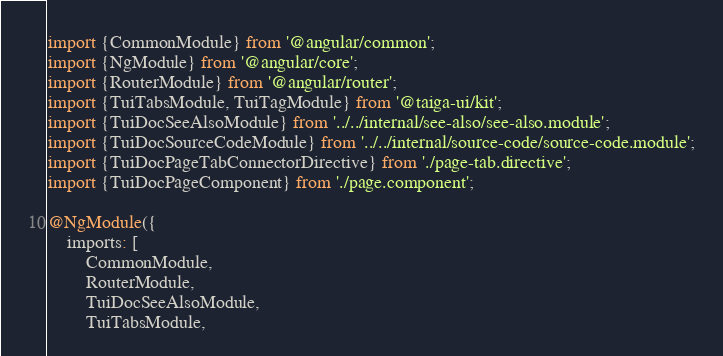Convert code to text. <code><loc_0><loc_0><loc_500><loc_500><_TypeScript_>import {CommonModule} from '@angular/common';
import {NgModule} from '@angular/core';
import {RouterModule} from '@angular/router';
import {TuiTabsModule, TuiTagModule} from '@taiga-ui/kit';
import {TuiDocSeeAlsoModule} from '../../internal/see-also/see-also.module';
import {TuiDocSourceCodeModule} from '../../internal/source-code/source-code.module';
import {TuiDocPageTabConnectorDirective} from './page-tab.directive';
import {TuiDocPageComponent} from './page.component';

@NgModule({
    imports: [
        CommonModule,
        RouterModule,
        TuiDocSeeAlsoModule,
        TuiTabsModule,</code> 